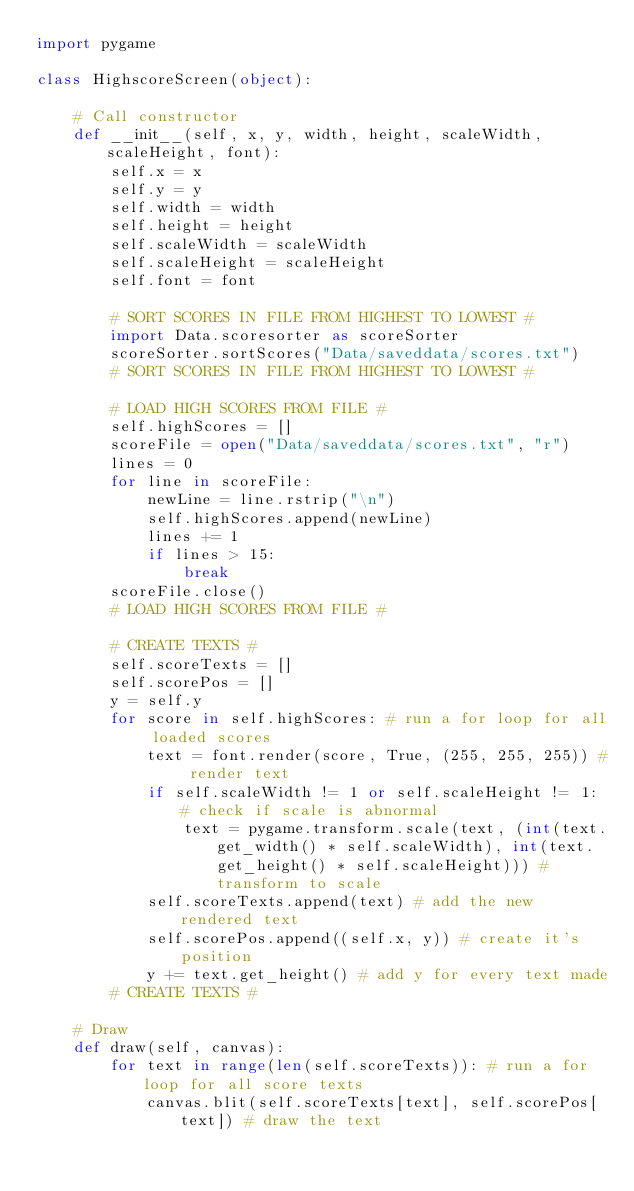<code> <loc_0><loc_0><loc_500><loc_500><_Python_>import pygame

class HighscoreScreen(object):

    # Call constructor
    def __init__(self, x, y, width, height, scaleWidth, scaleHeight, font):
        self.x = x
        self.y = y
        self.width = width
        self.height = height
        self.scaleWidth = scaleWidth
        self.scaleHeight = scaleHeight
        self.font = font

        # SORT SCORES IN FILE FROM HIGHEST TO LOWEST #
        import Data.scoresorter as scoreSorter
        scoreSorter.sortScores("Data/saveddata/scores.txt")
        # SORT SCORES IN FILE FROM HIGHEST TO LOWEST #

        # LOAD HIGH SCORES FROM FILE #
        self.highScores = []
        scoreFile = open("Data/saveddata/scores.txt", "r")
        lines = 0
        for line in scoreFile:
            newLine = line.rstrip("\n")
            self.highScores.append(newLine)
            lines += 1
            if lines > 15:
                break
        scoreFile.close()
        # LOAD HIGH SCORES FROM FILE #

        # CREATE TEXTS #
        self.scoreTexts = []
        self.scorePos = []
        y = self.y
        for score in self.highScores: # run a for loop for all loaded scores
            text = font.render(score, True, (255, 255, 255)) # render text
            if self.scaleWidth != 1 or self.scaleHeight != 1: # check if scale is abnormal
                text = pygame.transform.scale(text, (int(text.get_width() * self.scaleWidth), int(text.get_height() * self.scaleHeight))) # transform to scale
            self.scoreTexts.append(text) # add the new rendered text
            self.scorePos.append((self.x, y)) # create it's position
            y += text.get_height() # add y for every text made
        # CREATE TEXTS #

    # Draw
    def draw(self, canvas):
        for text in range(len(self.scoreTexts)): # run a for loop for all score texts
            canvas.blit(self.scoreTexts[text], self.scorePos[text]) # draw the text
</code> 